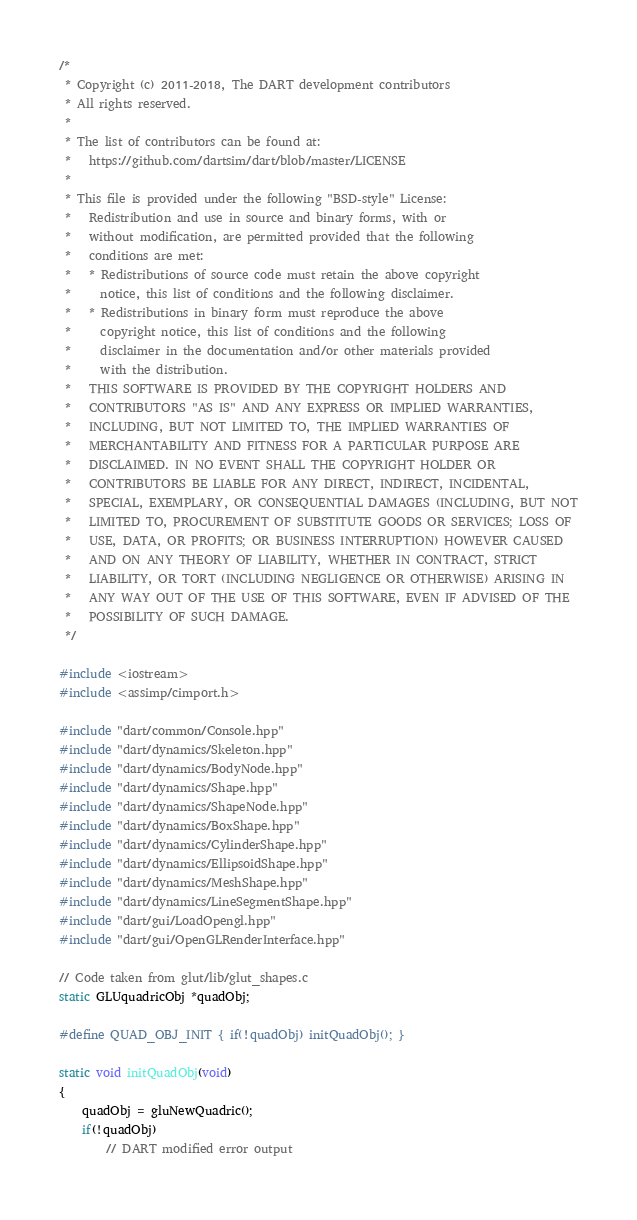Convert code to text. <code><loc_0><loc_0><loc_500><loc_500><_C++_>/*
 * Copyright (c) 2011-2018, The DART development contributors
 * All rights reserved.
 *
 * The list of contributors can be found at:
 *   https://github.com/dartsim/dart/blob/master/LICENSE
 *
 * This file is provided under the following "BSD-style" License:
 *   Redistribution and use in source and binary forms, with or
 *   without modification, are permitted provided that the following
 *   conditions are met:
 *   * Redistributions of source code must retain the above copyright
 *     notice, this list of conditions and the following disclaimer.
 *   * Redistributions in binary form must reproduce the above
 *     copyright notice, this list of conditions and the following
 *     disclaimer in the documentation and/or other materials provided
 *     with the distribution.
 *   THIS SOFTWARE IS PROVIDED BY THE COPYRIGHT HOLDERS AND
 *   CONTRIBUTORS "AS IS" AND ANY EXPRESS OR IMPLIED WARRANTIES,
 *   INCLUDING, BUT NOT LIMITED TO, THE IMPLIED WARRANTIES OF
 *   MERCHANTABILITY AND FITNESS FOR A PARTICULAR PURPOSE ARE
 *   DISCLAIMED. IN NO EVENT SHALL THE COPYRIGHT HOLDER OR
 *   CONTRIBUTORS BE LIABLE FOR ANY DIRECT, INDIRECT, INCIDENTAL,
 *   SPECIAL, EXEMPLARY, OR CONSEQUENTIAL DAMAGES (INCLUDING, BUT NOT
 *   LIMITED TO, PROCUREMENT OF SUBSTITUTE GOODS OR SERVICES; LOSS OF
 *   USE, DATA, OR PROFITS; OR BUSINESS INTERRUPTION) HOWEVER CAUSED
 *   AND ON ANY THEORY OF LIABILITY, WHETHER IN CONTRACT, STRICT
 *   LIABILITY, OR TORT (INCLUDING NEGLIGENCE OR OTHERWISE) ARISING IN
 *   ANY WAY OUT OF THE USE OF THIS SOFTWARE, EVEN IF ADVISED OF THE
 *   POSSIBILITY OF SUCH DAMAGE.
 */

#include <iostream>
#include <assimp/cimport.h>

#include "dart/common/Console.hpp"
#include "dart/dynamics/Skeleton.hpp"
#include "dart/dynamics/BodyNode.hpp"
#include "dart/dynamics/Shape.hpp"
#include "dart/dynamics/ShapeNode.hpp"
#include "dart/dynamics/BoxShape.hpp"
#include "dart/dynamics/CylinderShape.hpp"
#include "dart/dynamics/EllipsoidShape.hpp"
#include "dart/dynamics/MeshShape.hpp"
#include "dart/dynamics/LineSegmentShape.hpp"
#include "dart/gui/LoadOpengl.hpp"
#include "dart/gui/OpenGLRenderInterface.hpp"

// Code taken from glut/lib/glut_shapes.c
static GLUquadricObj *quadObj;

#define QUAD_OBJ_INIT { if(!quadObj) initQuadObj(); }

static void initQuadObj(void)
{
    quadObj = gluNewQuadric();
    if(!quadObj)
        // DART modified error output</code> 